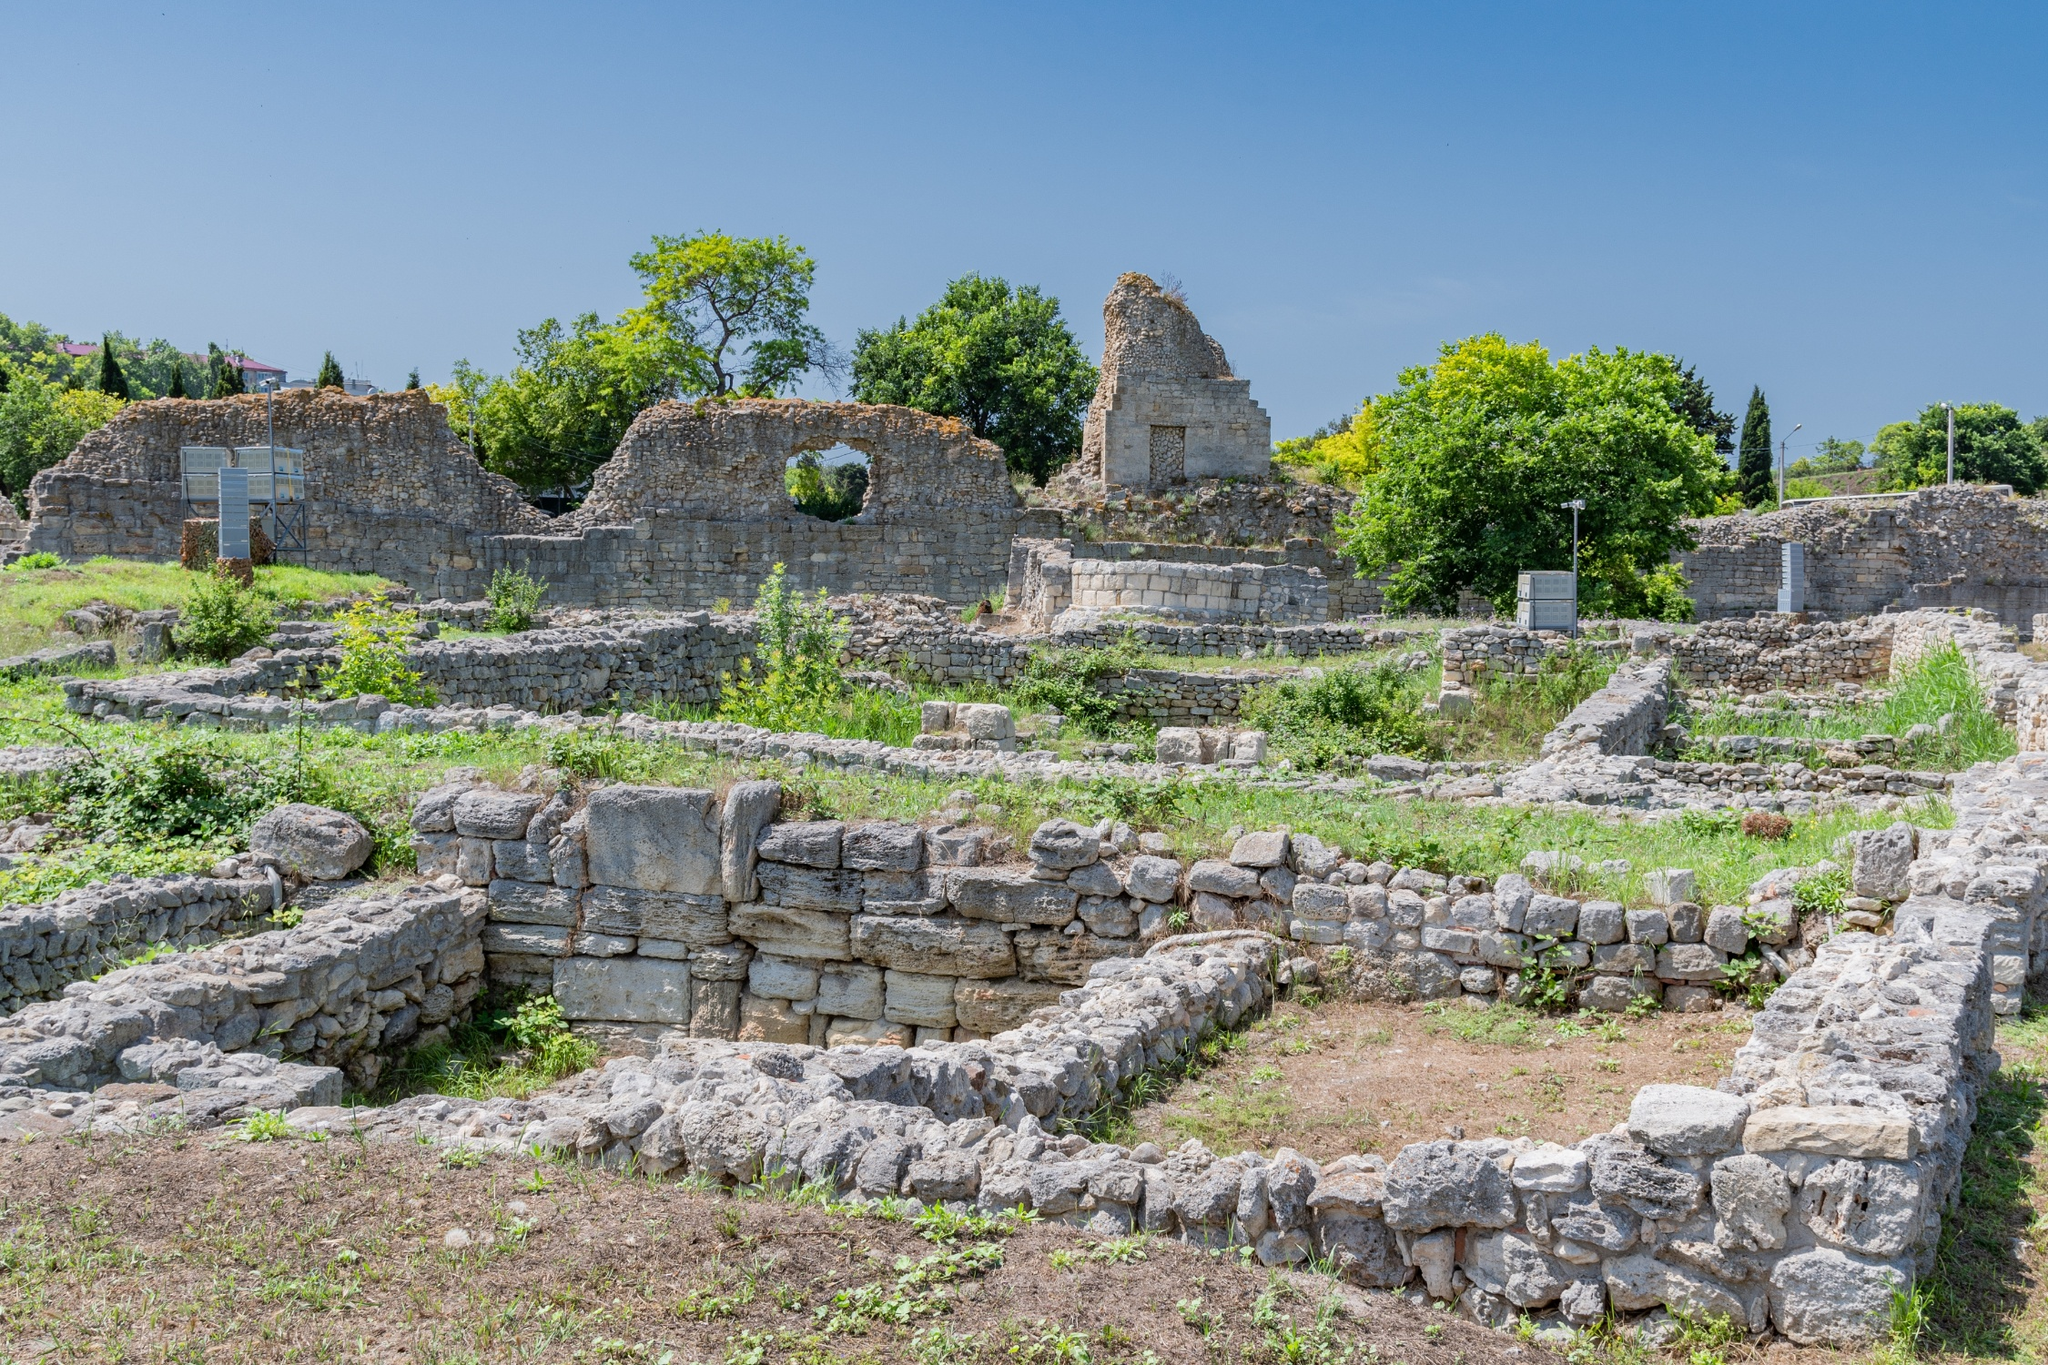What's happening in the scene? The scene captures a mesmerizing glimpse into the past with remnants of an ancient city. The ruins, aged and weather-worn, stand steadfast amidst a verdant landscape. A prominent wall, with a large hole where a window once stood, hints at the structure's former grandeur. Nearby, a smaller wall with a doorway seems to mark the entrance to another significant building. Scattered throughout the area are fragments of smaller structures whose original purposes have been lost to history. The greenery of the grass and trees juxtaposes the lifeless gray stone, hinting at the rebirth of nature over human achievements. The blue sky, dotted with clouds, adds to the serene atmosphere, making the scene a poignant reminder of the transient nature of civilizations and their endeavors. 